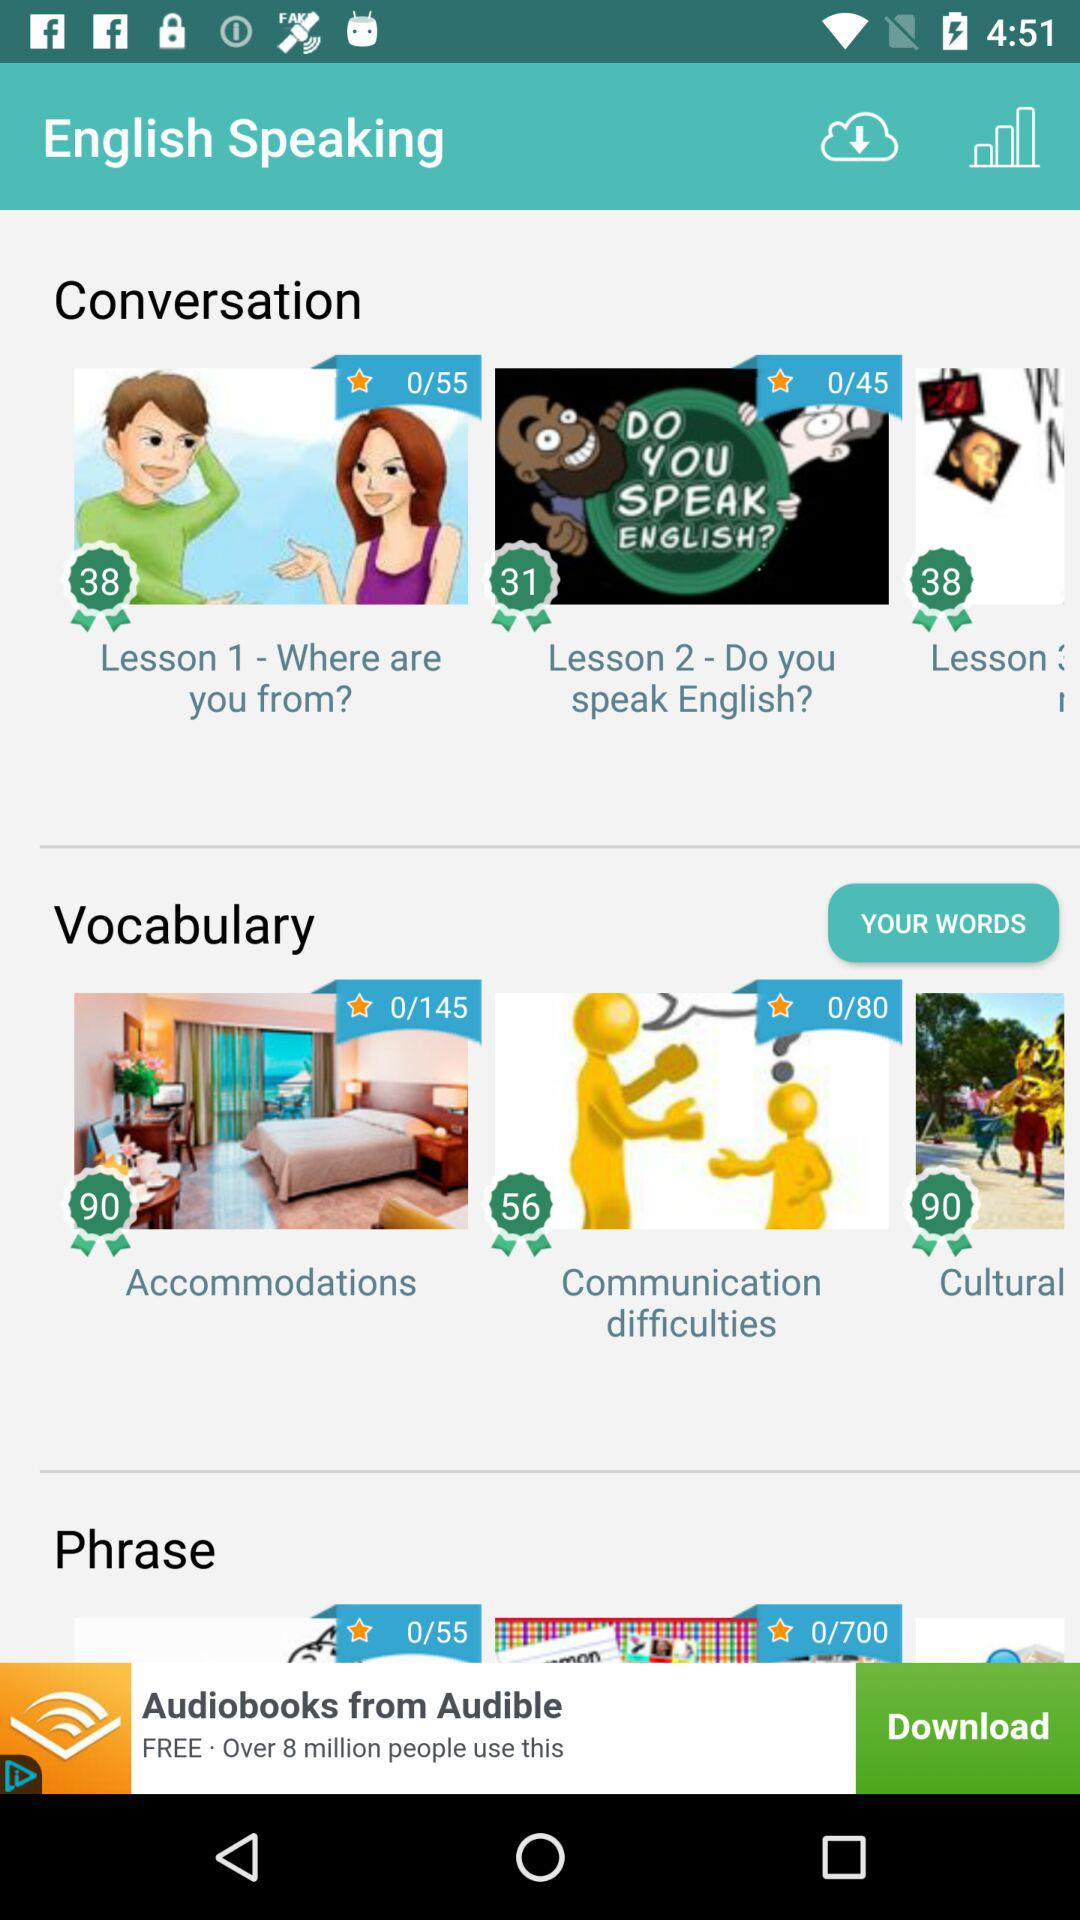What is the application name? The application name is "English Speaking". 